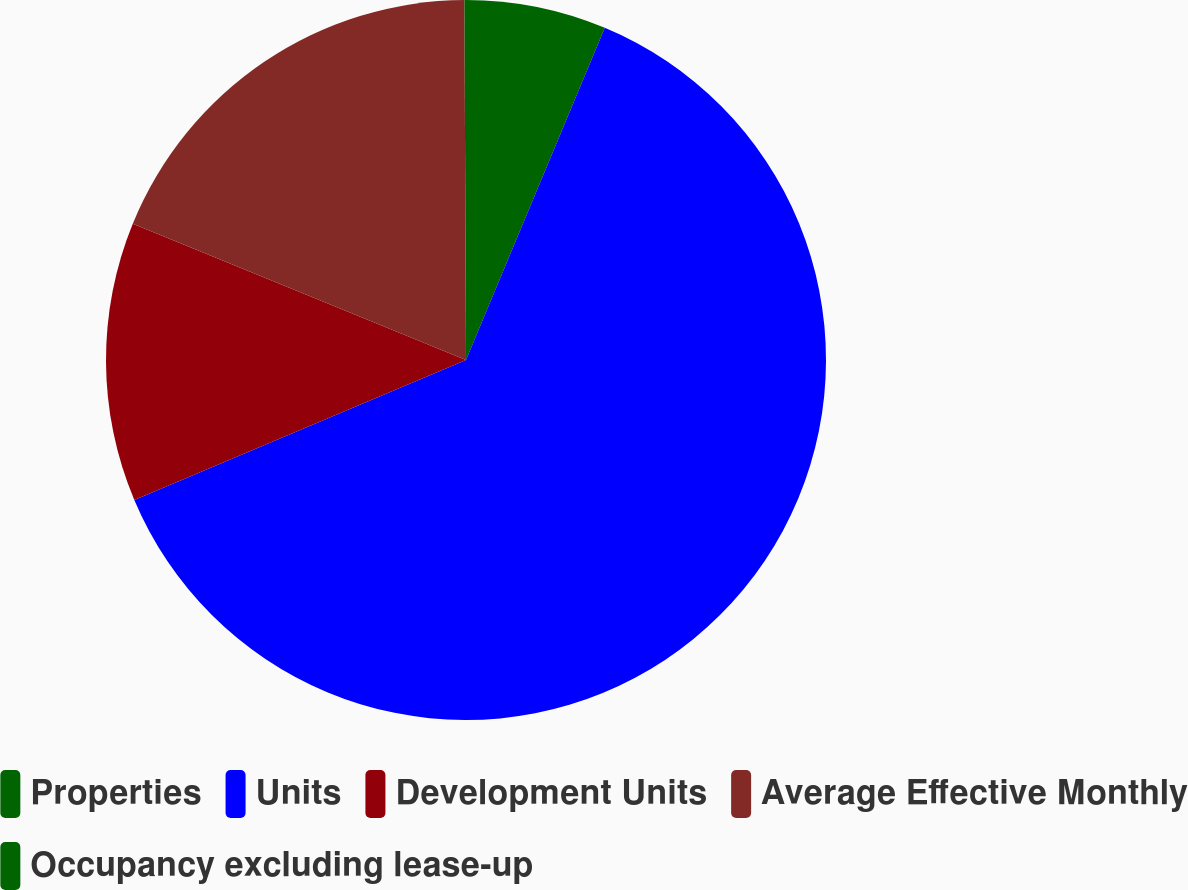Convert chart. <chart><loc_0><loc_0><loc_500><loc_500><pie_chart><fcel>Properties<fcel>Units<fcel>Development Units<fcel>Average Effective Monthly<fcel>Occupancy excluding lease-up<nl><fcel>6.3%<fcel>62.34%<fcel>12.53%<fcel>18.75%<fcel>0.07%<nl></chart> 